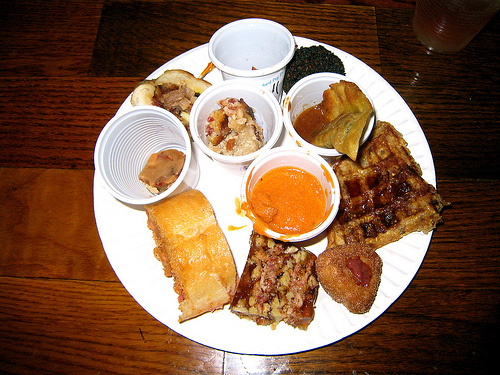<image>
Is the peanut brittle on the plate? No. The peanut brittle is not positioned on the plate. They may be near each other, but the peanut brittle is not supported by or resting on top of the plate. 